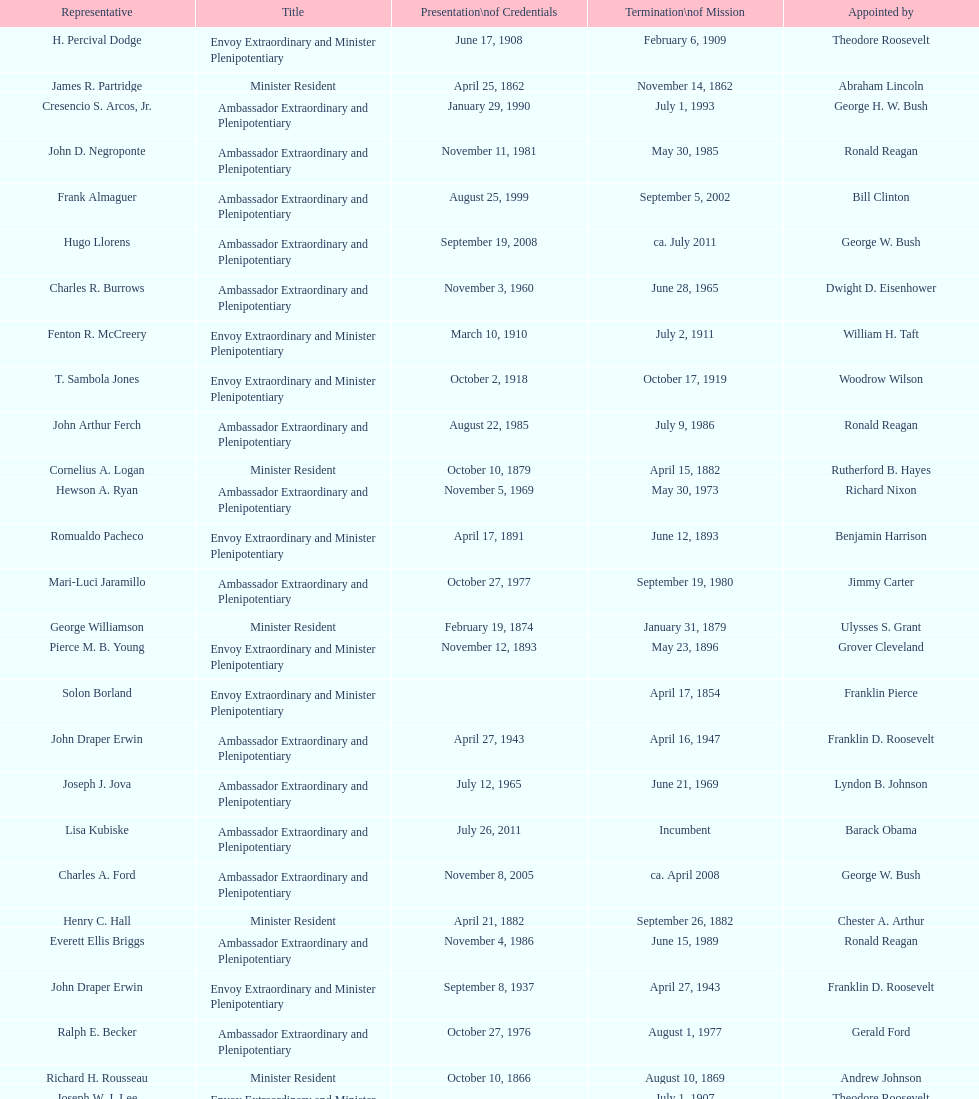Could you parse the entire table as a dict? {'header': ['Representative', 'Title', 'Presentation\\nof Credentials', 'Termination\\nof Mission', 'Appointed by'], 'rows': [['H. Percival Dodge', 'Envoy Extraordinary and Minister Plenipotentiary', 'June 17, 1908', 'February 6, 1909', 'Theodore Roosevelt'], ['James R. Partridge', 'Minister Resident', 'April 25, 1862', 'November 14, 1862', 'Abraham Lincoln'], ['Cresencio S. Arcos, Jr.', 'Ambassador Extraordinary and Plenipotentiary', 'January 29, 1990', 'July 1, 1993', 'George H. W. Bush'], ['John D. Negroponte', 'Ambassador Extraordinary and Plenipotentiary', 'November 11, 1981', 'May 30, 1985', 'Ronald Reagan'], ['Frank Almaguer', 'Ambassador Extraordinary and Plenipotentiary', 'August 25, 1999', 'September 5, 2002', 'Bill Clinton'], ['Hugo Llorens', 'Ambassador Extraordinary and Plenipotentiary', 'September 19, 2008', 'ca. July 2011', 'George W. Bush'], ['Charles R. Burrows', 'Ambassador Extraordinary and Plenipotentiary', 'November 3, 1960', 'June 28, 1965', 'Dwight D. Eisenhower'], ['Fenton R. McCreery', 'Envoy Extraordinary and Minister Plenipotentiary', 'March 10, 1910', 'July 2, 1911', 'William H. Taft'], ['T. Sambola Jones', 'Envoy Extraordinary and Minister Plenipotentiary', 'October 2, 1918', 'October 17, 1919', 'Woodrow Wilson'], ['John Arthur Ferch', 'Ambassador Extraordinary and Plenipotentiary', 'August 22, 1985', 'July 9, 1986', 'Ronald Reagan'], ['Cornelius A. Logan', 'Minister Resident', 'October 10, 1879', 'April 15, 1882', 'Rutherford B. Hayes'], ['Hewson A. Ryan', 'Ambassador Extraordinary and Plenipotentiary', 'November 5, 1969', 'May 30, 1973', 'Richard Nixon'], ['Romualdo Pacheco', 'Envoy Extraordinary and Minister Plenipotentiary', 'April 17, 1891', 'June 12, 1893', 'Benjamin Harrison'], ['Mari-Luci Jaramillo', 'Ambassador Extraordinary and Plenipotentiary', 'October 27, 1977', 'September 19, 1980', 'Jimmy Carter'], ['George Williamson', 'Minister Resident', 'February 19, 1874', 'January 31, 1879', 'Ulysses S. Grant'], ['Pierce M. B. Young', 'Envoy Extraordinary and Minister Plenipotentiary', 'November 12, 1893', 'May 23, 1896', 'Grover Cleveland'], ['Solon Borland', 'Envoy Extraordinary and Minister Plenipotentiary', '', 'April 17, 1854', 'Franklin Pierce'], ['John Draper Erwin', 'Ambassador Extraordinary and Plenipotentiary', 'April 27, 1943', 'April 16, 1947', 'Franklin D. Roosevelt'], ['Joseph J. Jova', 'Ambassador Extraordinary and Plenipotentiary', 'July 12, 1965', 'June 21, 1969', 'Lyndon B. Johnson'], ['Lisa Kubiske', 'Ambassador Extraordinary and Plenipotentiary', 'July 26, 2011', 'Incumbent', 'Barack Obama'], ['Charles A. Ford', 'Ambassador Extraordinary and Plenipotentiary', 'November 8, 2005', 'ca. April 2008', 'George W. Bush'], ['Henry C. Hall', 'Minister Resident', 'April 21, 1882', 'September 26, 1882', 'Chester A. Arthur'], ['Everett Ellis Briggs', 'Ambassador Extraordinary and Plenipotentiary', 'November 4, 1986', 'June 15, 1989', 'Ronald Reagan'], ['John Draper Erwin', 'Envoy Extraordinary and Minister Plenipotentiary', 'September 8, 1937', 'April 27, 1943', 'Franklin D. Roosevelt'], ['Ralph E. Becker', 'Ambassador Extraordinary and Plenipotentiary', 'October 27, 1976', 'August 1, 1977', 'Gerald Ford'], ['Richard H. Rousseau', 'Minister Resident', 'October 10, 1866', 'August 10, 1869', 'Andrew Johnson'], ['Joseph W. J. Lee', 'Envoy Extraordinary and Minister Plenipotentiary', '', 'July 1, 1907', 'Theodore Roosevelt'], ['Franklin E. Morales', 'Envoy Extraordinary and Minister Plenipotentiary', 'January 18, 1922', 'March 2, 1925', 'Warren G. Harding'], ['Phillip V. Sanchez', 'Ambassador Extraordinary and Plenipotentiary', 'June 15, 1973', 'July 17, 1976', 'Richard Nixon'], ['George T. Summerlin', 'Envoy Extraordinary and Minister Plenipotentiary', 'November 21, 1925', 'December 17, 1929', 'Calvin Coolidge'], ['Beverly L. Clarke', 'Minister Resident', 'August 10, 1858', 'March 17, 1860', 'James Buchanan'], ['Henry Baxter', 'Minister Resident', 'August 10, 1869', 'June 30, 1873', 'Ulysses S. Grant'], ['Charles Dunning White', 'Envoy Extraordinary and Minister Plenipotentiary', 'September 9, 1911', 'November 4, 1913', 'William H. Taft'], ['Whiting Willauer', 'Ambassador Extraordinary and Plenipotentiary', 'March 5, 1954', 'March 24, 1958', 'Dwight D. Eisenhower'], ['Philip Marshall Brown', 'Envoy Extraordinary and Minister Plenipotentiary', 'February 21, 1909', 'February 26, 1910', 'Theodore Roosevelt'], ['Robert Newbegin', 'Ambassador Extraordinary and Plenipotentiary', 'April 30, 1958', 'August 3, 1960', 'Dwight D. Eisenhower'], ['Herbert S. Bursley', 'Ambassador Extraordinary and Plenipotentiary', 'May 15, 1948', 'December 12, 1950', 'Harry S. Truman'], ['Larry Leon Palmer', 'Ambassador Extraordinary and Plenipotentiary', 'October 8, 2002', 'May 7, 2005', 'George W. Bush'], ['William Thornton Pryce', 'Ambassador Extraordinary and Plenipotentiary', 'July 21, 1993', 'August 15, 1996', 'Bill Clinton'], ['John Draper Erwin', 'Ambassador Extraordinary and Plenipotentiary', 'March 14, 1951', 'February 28, 1954', 'Harry S. Truman'], ['James F. Creagan', 'Ambassador Extraordinary and Plenipotentiary', 'August 29, 1996', 'July 20, 1999', 'Bill Clinton'], ['Paul C. Daniels', 'Ambassador Extraordinary and Plenipotentiary', 'June 23, 1947', 'October 30, 1947', 'Harry S. Truman'], ['Leo J. Keena', 'Envoy Extraordinary and Minister Plenipotentiary', 'July 19, 1935', 'May 1, 1937', 'Franklin D. Roosevelt'], ['Macgrane Coxe', 'Envoy Extraordinary and Minister Plenipotentiary', '', 'June 30, 1897', 'Grover Cleveland'], ['W. Godfrey Hunter', 'Envoy Extraordinary and Minister Plenipotentiary', 'January 19, 1899', 'February 2, 1903', 'William McKinley'], ['Leslie Combs', 'Envoy Extraordinary and Minister Plenipotentiary', 'May 22, 1903', 'February 27, 1907', 'Theodore Roosevelt'], ['John Ewing', 'Envoy Extraordinary and Minister Plenipotentiary', 'December 26, 1913', 'January 18, 1918', 'Woodrow Wilson'], ['Lansing B. Mizner', 'Envoy Extraordinary and Minister Plenipotentiary', 'March 30, 1889', 'December 31, 1890', 'Benjamin Harrison'], ['Thomas H. Clay', 'Minister Resident', 'April 5, 1864', 'August 10, 1866', 'Abraham Lincoln'], ['Julius G. Lay', 'Envoy Extraordinary and Minister Plenipotentiary', 'May 31, 1930', 'March 17, 1935', 'Herbert Hoover'], ['Henry C. Hall', 'Envoy Extraordinary and Minister Plenipotentiary', 'September 26, 1882', 'May 16, 1889', 'Chester A. Arthur'], ['Jack R. Binns', 'Ambassador Extraordinary and Plenipotentiary', 'October 10, 1980', 'October 31, 1981', 'Jimmy Carter']]} Who was the last representative picked? Lisa Kubiske. 